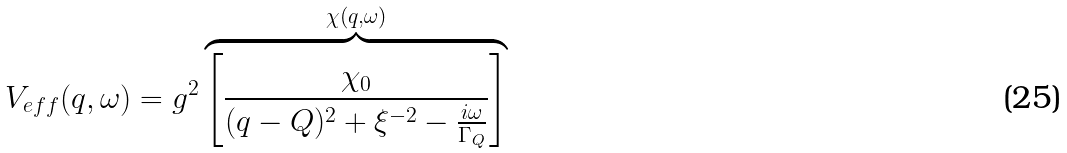<formula> <loc_0><loc_0><loc_500><loc_500>V _ { e f f } ( { q } , \omega ) = g ^ { 2 } \overbrace { \left [ \frac { \chi _ { 0 } } { ( { q } - { Q } ) ^ { 2 } + \xi ^ { - 2 } - \frac { i \omega } { \Gamma _ { Q } } } \right ] } ^ { { \chi ( { q } , \omega ) } }</formula> 